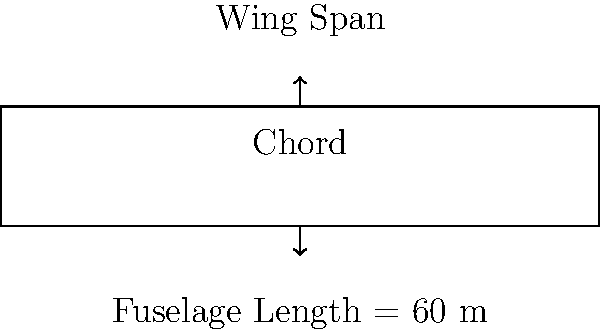As an impressed flight enthusiast, you're examining a new aircraft design. The fuselage length is 60 meters, and the wing's aspect ratio is 8. If the aspect ratio is defined as the square of the wing span divided by the wing area, and the wing area is 450 square meters, what is the wing span of this aircraft? Let's approach this step-by-step:

1) We are given:
   - Fuselage length = 60 m (not needed for this calculation)
   - Aspect ratio (AR) = 8
   - Wing area (S) = 450 m²

2) The aspect ratio formula is:
   $$ AR = \frac{b^2}{S} $$
   Where b is the wing span and S is the wing area.

3) We know AR and S, so let's substitute these values:
   $$ 8 = \frac{b^2}{450} $$

4) Now, let's solve for b:
   $$ 8 \times 450 = b^2 $$
   $$ 3600 = b^2 $$

5) To get b, we take the square root of both sides:
   $$ b = \sqrt{3600} = 60 $$

Therefore, the wing span is 60 meters.
Answer: 60 meters 